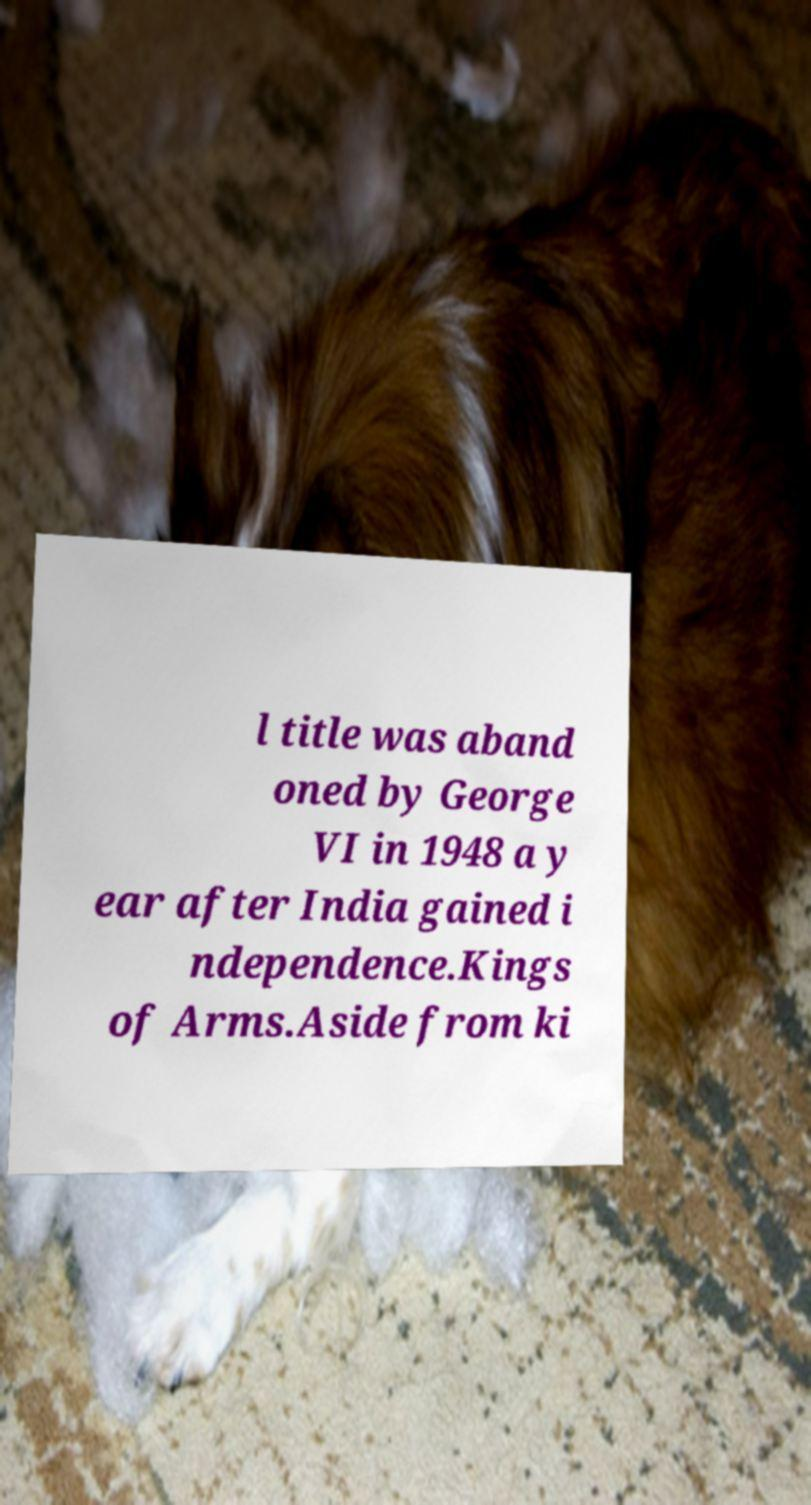Could you extract and type out the text from this image? l title was aband oned by George VI in 1948 a y ear after India gained i ndependence.Kings of Arms.Aside from ki 